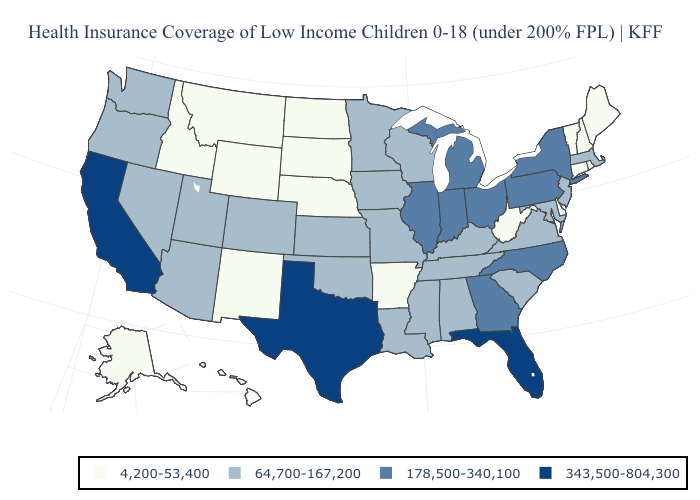What is the highest value in the USA?
Be succinct. 343,500-804,300. What is the value of Georgia?
Write a very short answer. 178,500-340,100. What is the lowest value in the West?
Give a very brief answer. 4,200-53,400. Which states have the lowest value in the USA?
Keep it brief. Alaska, Arkansas, Connecticut, Delaware, Hawaii, Idaho, Maine, Montana, Nebraska, New Hampshire, New Mexico, North Dakota, Rhode Island, South Dakota, Vermont, West Virginia, Wyoming. What is the highest value in states that border Washington?
Answer briefly. 64,700-167,200. Among the states that border New Jersey , does Delaware have the lowest value?
Be succinct. Yes. Does the first symbol in the legend represent the smallest category?
Concise answer only. Yes. Name the states that have a value in the range 4,200-53,400?
Write a very short answer. Alaska, Arkansas, Connecticut, Delaware, Hawaii, Idaho, Maine, Montana, Nebraska, New Hampshire, New Mexico, North Dakota, Rhode Island, South Dakota, Vermont, West Virginia, Wyoming. Is the legend a continuous bar?
Answer briefly. No. Which states have the lowest value in the MidWest?
Answer briefly. Nebraska, North Dakota, South Dakota. What is the lowest value in the USA?
Answer briefly. 4,200-53,400. Among the states that border North Carolina , does Georgia have the lowest value?
Short answer required. No. Does the map have missing data?
Write a very short answer. No. What is the value of Maryland?
Answer briefly. 64,700-167,200. Does Texas have the highest value in the South?
Keep it brief. Yes. 